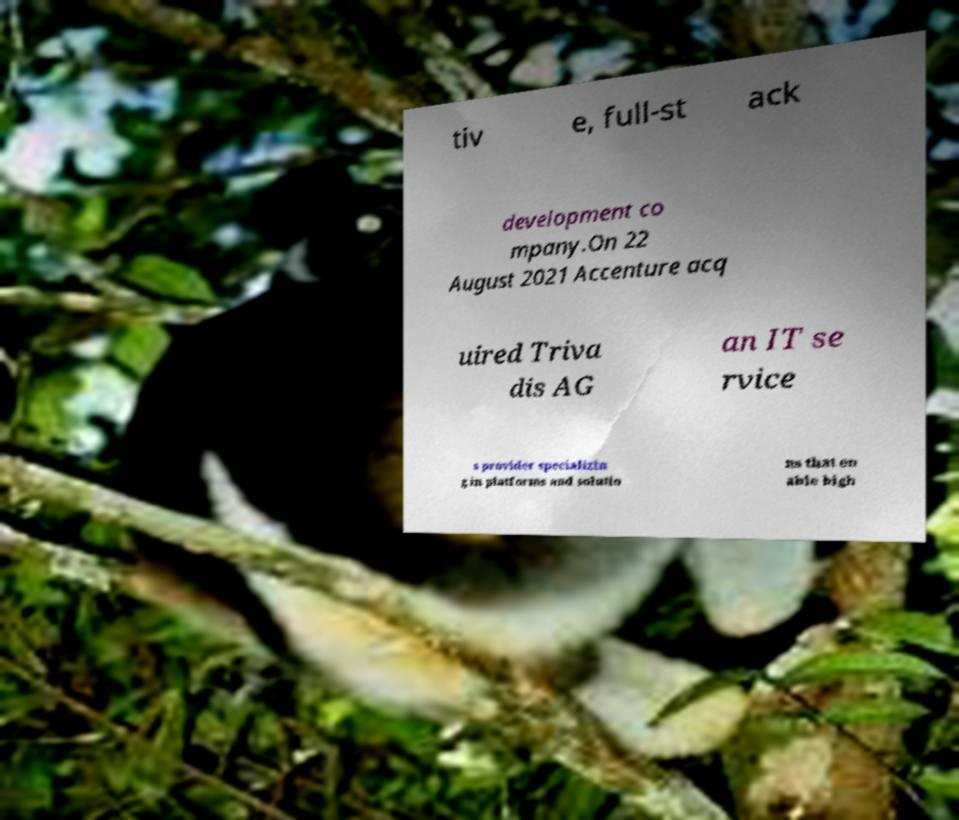Could you extract and type out the text from this image? tiv e, full-st ack development co mpany.On 22 August 2021 Accenture acq uired Triva dis AG an IT se rvice s provider specializin g in platforms and solutio ns that en able high 